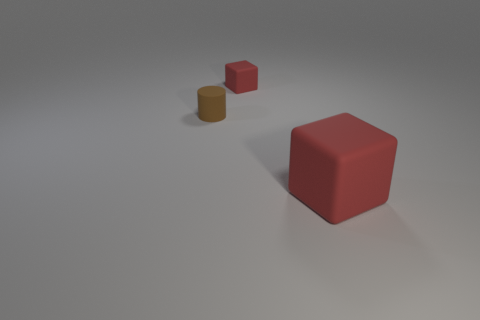There is another thing that is the same shape as the big red object; what material is it?
Keep it short and to the point. Rubber. How many big rubber blocks are on the left side of the red thing behind the large red cube?
Your response must be concise. 0. What is the size of the matte cube in front of the small matte object in front of the block that is to the left of the large red matte object?
Keep it short and to the point. Large. The thing that is on the left side of the red block that is behind the big red rubber object is what color?
Offer a terse response. Brown. How many other objects are the same color as the cylinder?
Offer a very short reply. 0. There is a cube that is in front of the red matte object that is behind the big red cube; what is its material?
Offer a terse response. Rubber. Are there any small rubber cylinders?
Give a very brief answer. Yes. How big is the block that is left of the red rubber thing right of the small red thing?
Your answer should be very brief. Small. Is the number of tiny rubber cylinders that are in front of the tiny cylinder greater than the number of small brown cylinders that are behind the big matte cube?
Provide a succinct answer. No. What number of cubes are either brown things or red rubber things?
Make the answer very short. 2. 